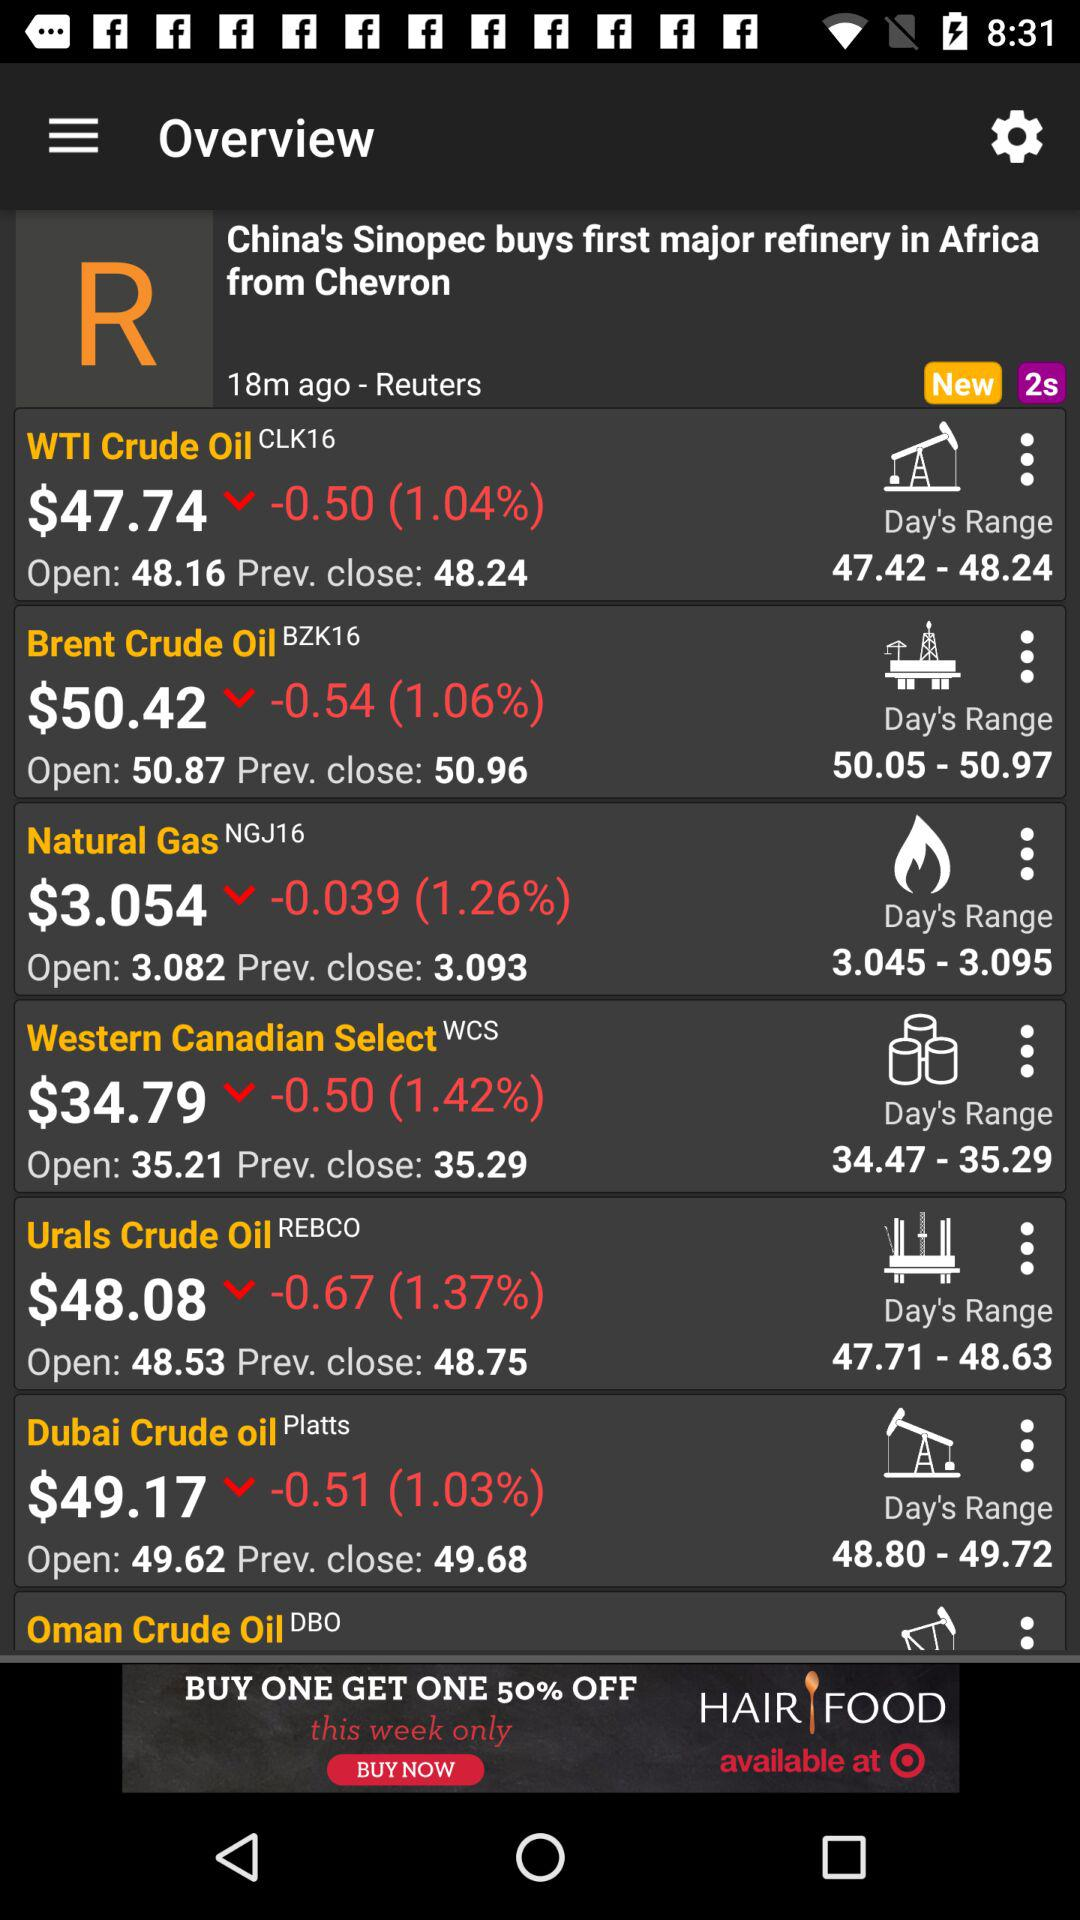What is the day's price range for "Brent Crude Oil"? The day's price range for "Brent Crude Oil" is 50.05 to 50.97. 